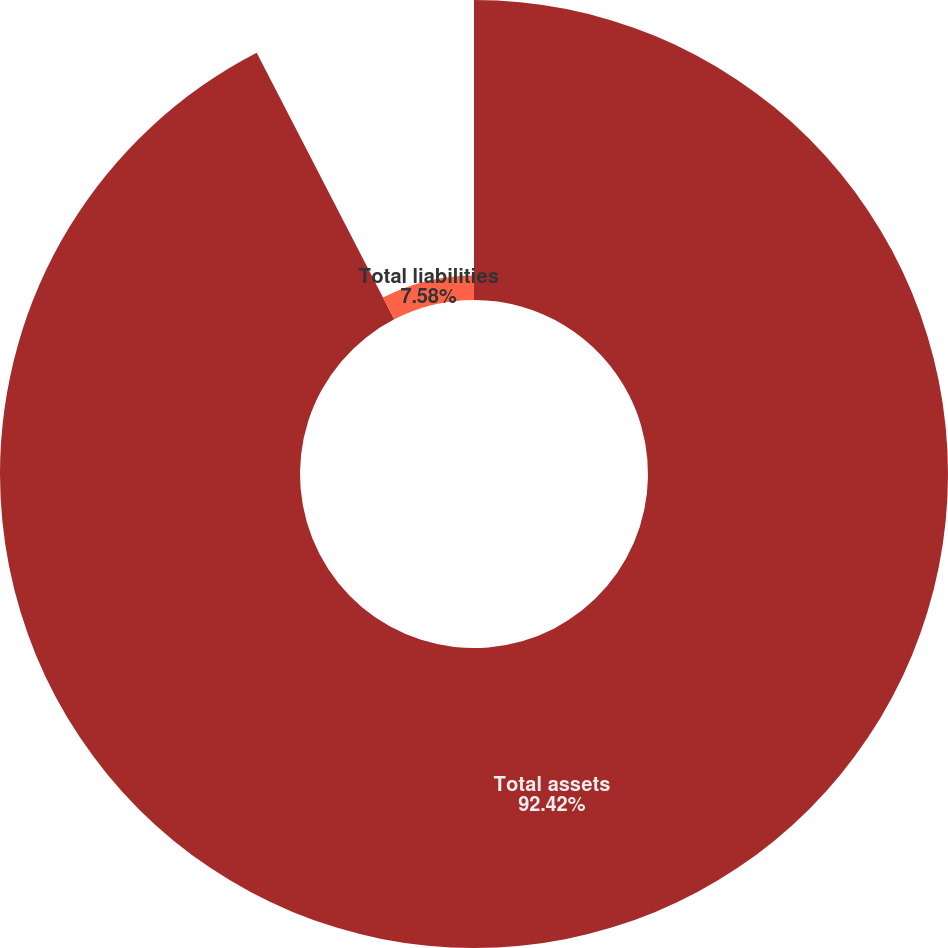Convert chart to OTSL. <chart><loc_0><loc_0><loc_500><loc_500><pie_chart><fcel>Total assets<fcel>Total liabilities<nl><fcel>92.42%<fcel>7.58%<nl></chart> 